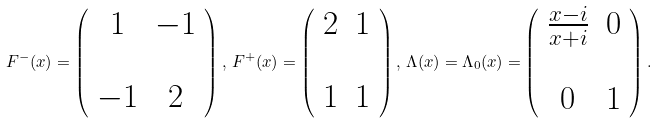Convert formula to latex. <formula><loc_0><loc_0><loc_500><loc_500>F ^ { - } ( x ) = \left ( \begin{array} { c c } 1 & - 1 \\ & \\ - 1 & 2 \end{array} \right ) , \, F ^ { + } ( x ) = \left ( \begin{array} { c c } 2 & 1 \\ & \\ 1 & 1 \end{array} \right ) , \, \Lambda ( x ) = { \Lambda _ { 0 } ( x ) = } \left ( \begin{array} { c c } \frac { x - i } { x + i } & 0 \\ & \\ 0 & 1 \end{array} \right ) .</formula> 